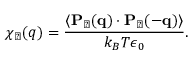Convert formula to latex. <formula><loc_0><loc_0><loc_500><loc_500>\chi _ { \perp } ( q ) = \frac { \langle { P } _ { \perp } ( { q } ) \cdot { P } _ { \perp } ( { - q } ) \rangle } { k _ { B } T \epsilon _ { 0 } } .</formula> 